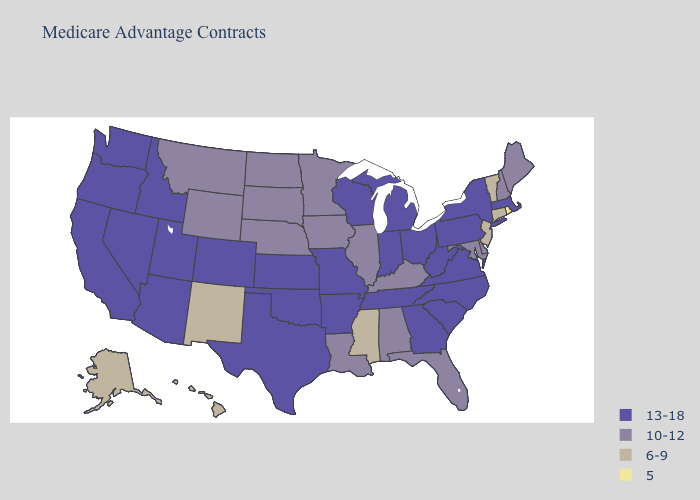What is the value of Georgia?
Quick response, please. 13-18. What is the lowest value in the West?
Give a very brief answer. 6-9. What is the lowest value in states that border Montana?
Concise answer only. 10-12. What is the lowest value in the South?
Quick response, please. 6-9. Name the states that have a value in the range 10-12?
Give a very brief answer. Alabama, Delaware, Florida, Iowa, Illinois, Kentucky, Louisiana, Maryland, Maine, Minnesota, Montana, North Dakota, Nebraska, New Hampshire, South Dakota, Wyoming. What is the lowest value in states that border Wyoming?
Be succinct. 10-12. What is the lowest value in the USA?
Concise answer only. 5. Does New York have a lower value than South Dakota?
Keep it brief. No. Name the states that have a value in the range 13-18?
Give a very brief answer. Arkansas, Arizona, California, Colorado, Georgia, Idaho, Indiana, Kansas, Massachusetts, Michigan, Missouri, North Carolina, Nevada, New York, Ohio, Oklahoma, Oregon, Pennsylvania, South Carolina, Tennessee, Texas, Utah, Virginia, Washington, Wisconsin, West Virginia. What is the value of Missouri?
Give a very brief answer. 13-18. What is the value of Pennsylvania?
Quick response, please. 13-18. Does the map have missing data?
Keep it brief. No. What is the lowest value in the South?
Concise answer only. 6-9. Name the states that have a value in the range 13-18?
Concise answer only. Arkansas, Arizona, California, Colorado, Georgia, Idaho, Indiana, Kansas, Massachusetts, Michigan, Missouri, North Carolina, Nevada, New York, Ohio, Oklahoma, Oregon, Pennsylvania, South Carolina, Tennessee, Texas, Utah, Virginia, Washington, Wisconsin, West Virginia. Name the states that have a value in the range 10-12?
Answer briefly. Alabama, Delaware, Florida, Iowa, Illinois, Kentucky, Louisiana, Maryland, Maine, Minnesota, Montana, North Dakota, Nebraska, New Hampshire, South Dakota, Wyoming. 